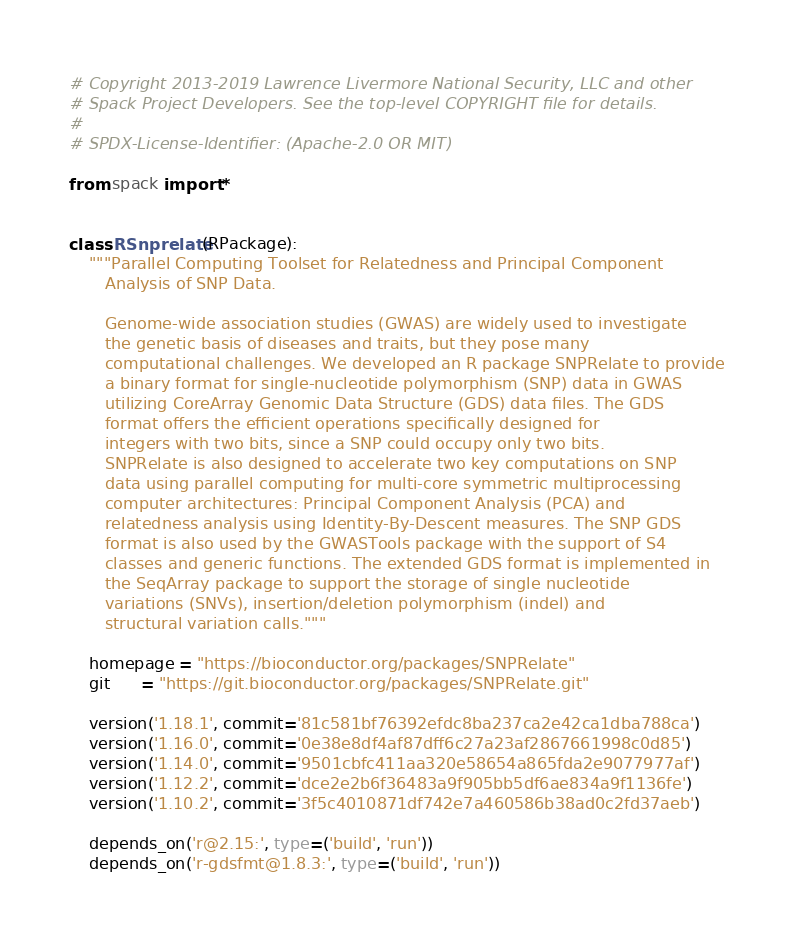<code> <loc_0><loc_0><loc_500><loc_500><_Python_># Copyright 2013-2019 Lawrence Livermore National Security, LLC and other
# Spack Project Developers. See the top-level COPYRIGHT file for details.
#
# SPDX-License-Identifier: (Apache-2.0 OR MIT)

from spack import *


class RSnprelate(RPackage):
    """Parallel Computing Toolset for Relatedness and Principal Component
       Analysis of SNP Data.

       Genome-wide association studies (GWAS) are widely used to investigate
       the genetic basis of diseases and traits, but they pose many
       computational challenges. We developed an R package SNPRelate to provide
       a binary format for single-nucleotide polymorphism (SNP) data in GWAS
       utilizing CoreArray Genomic Data Structure (GDS) data files. The GDS
       format offers the efficient operations specifically designed for
       integers with two bits, since a SNP could occupy only two bits.
       SNPRelate is also designed to accelerate two key computations on SNP
       data using parallel computing for multi-core symmetric multiprocessing
       computer architectures: Principal Component Analysis (PCA) and
       relatedness analysis using Identity-By-Descent measures. The SNP GDS
       format is also used by the GWASTools package with the support of S4
       classes and generic functions. The extended GDS format is implemented in
       the SeqArray package to support the storage of single nucleotide
       variations (SNVs), insertion/deletion polymorphism (indel) and
       structural variation calls."""

    homepage = "https://bioconductor.org/packages/SNPRelate"
    git      = "https://git.bioconductor.org/packages/SNPRelate.git"

    version('1.18.1', commit='81c581bf76392efdc8ba237ca2e42ca1dba788ca')
    version('1.16.0', commit='0e38e8df4af87dff6c27a23af2867661998c0d85')
    version('1.14.0', commit='9501cbfc411aa320e58654a865fda2e9077977af')
    version('1.12.2', commit='dce2e2b6f36483a9f905bb5df6ae834a9f1136fe')
    version('1.10.2', commit='3f5c4010871df742e7a460586b38ad0c2fd37aeb')

    depends_on('r@2.15:', type=('build', 'run'))
    depends_on('r-gdsfmt@1.8.3:', type=('build', 'run'))
</code> 